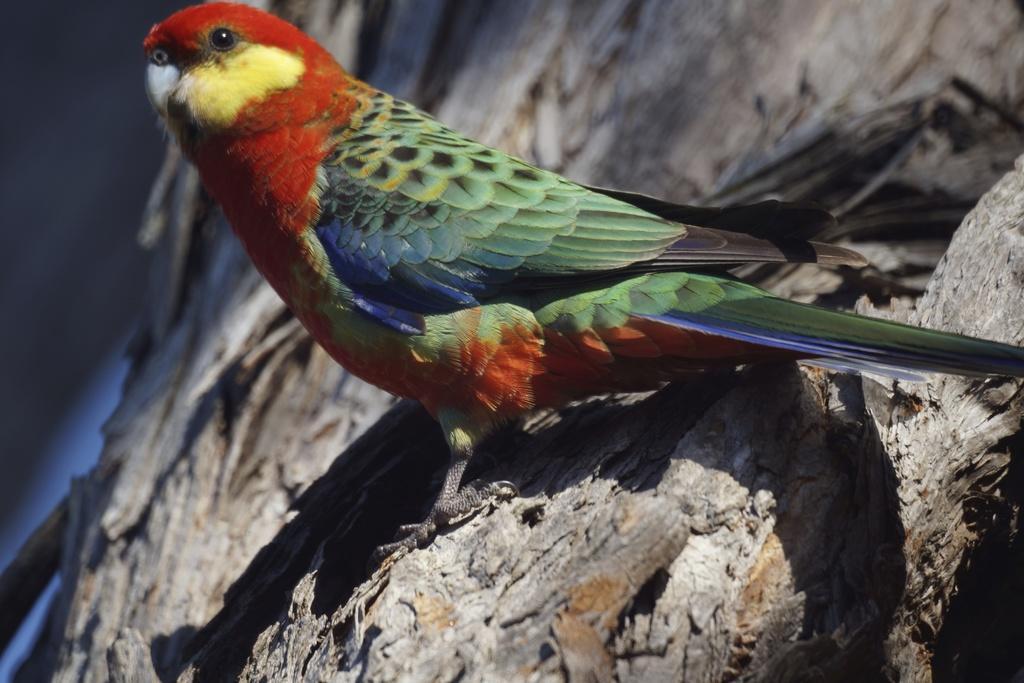Could you give a brief overview of what you see in this image? In this image we can see a bird on the branch of a tree. 